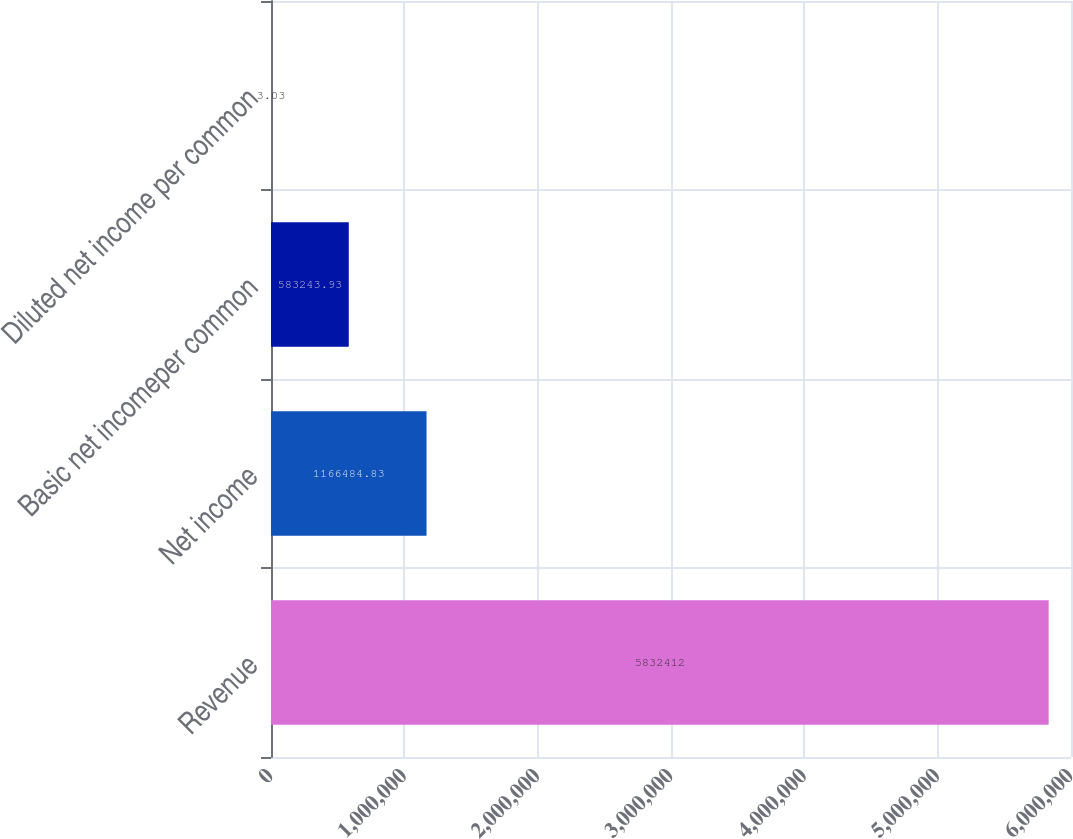Convert chart. <chart><loc_0><loc_0><loc_500><loc_500><bar_chart><fcel>Revenue<fcel>Net income<fcel>Basic net incomeper common<fcel>Diluted net income per common<nl><fcel>5.83241e+06<fcel>1.16648e+06<fcel>583244<fcel>3.03<nl></chart> 